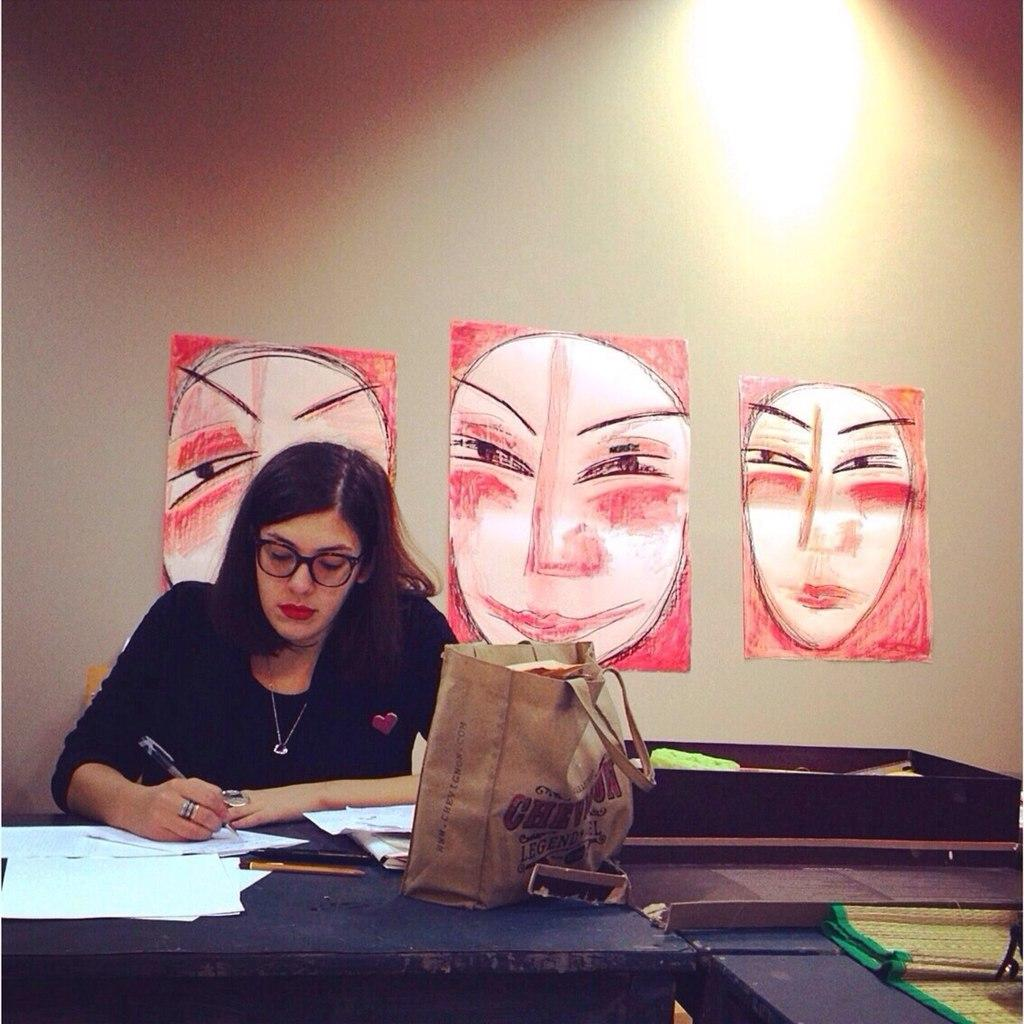Who is the main subject in the image? There is a lady in the image. What is the lady doing in the image? The lady is sitting on a chair. Where is the chair located in relation to the table? The chair is in front of a table. What items can be seen on the table? There are papers and a bag on the table. What is visible behind the lady? There are three posters behind the lady. How many balls are visible on the table in the image? There are no balls visible on the table in the image. What type of quince is being used as a decoration in the image? There is no quince present in the image. 